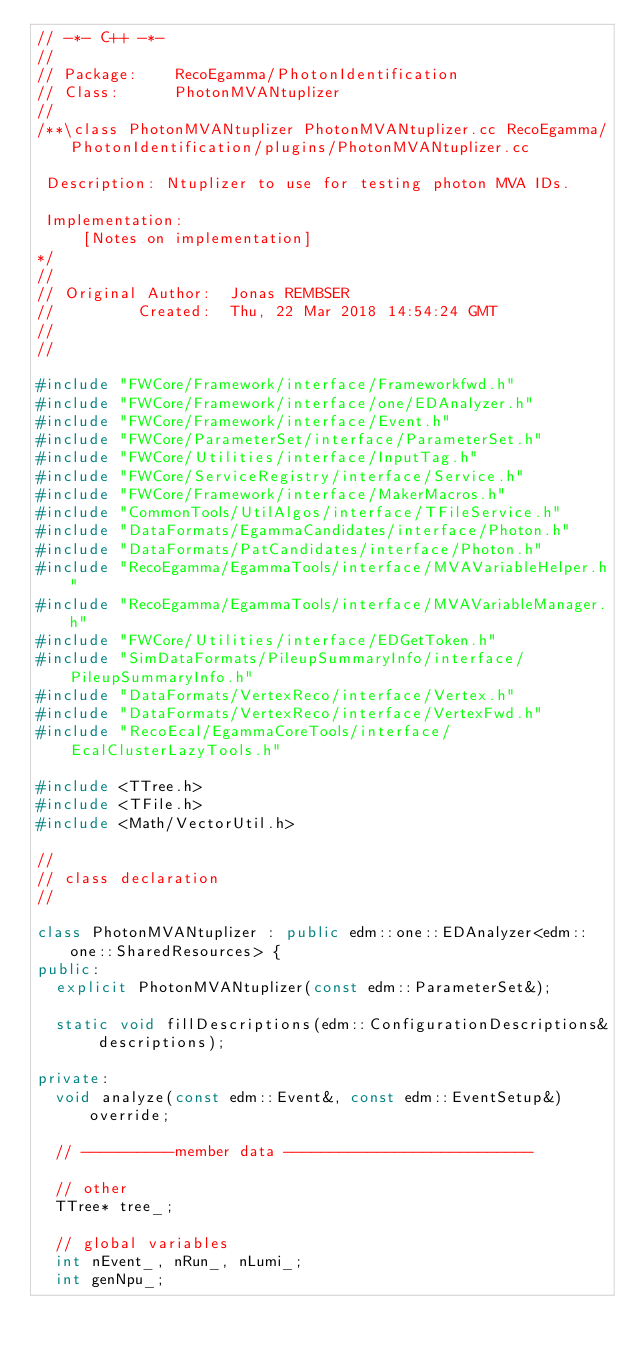Convert code to text. <code><loc_0><loc_0><loc_500><loc_500><_C++_>// -*- C++ -*-
//
// Package:    RecoEgamma/PhotonIdentification
// Class:      PhotonMVANtuplizer
//
/**\class PhotonMVANtuplizer PhotonMVANtuplizer.cc RecoEgamma/PhotonIdentification/plugins/PhotonMVANtuplizer.cc

 Description: Ntuplizer to use for testing photon MVA IDs.

 Implementation:
     [Notes on implementation]
*/
//
// Original Author:  Jonas REMBSER
//         Created:  Thu, 22 Mar 2018 14:54:24 GMT
//
//

#include "FWCore/Framework/interface/Frameworkfwd.h"
#include "FWCore/Framework/interface/one/EDAnalyzer.h"
#include "FWCore/Framework/interface/Event.h"
#include "FWCore/ParameterSet/interface/ParameterSet.h"
#include "FWCore/Utilities/interface/InputTag.h"
#include "FWCore/ServiceRegistry/interface/Service.h"
#include "FWCore/Framework/interface/MakerMacros.h"
#include "CommonTools/UtilAlgos/interface/TFileService.h"
#include "DataFormats/EgammaCandidates/interface/Photon.h"
#include "DataFormats/PatCandidates/interface/Photon.h"
#include "RecoEgamma/EgammaTools/interface/MVAVariableHelper.h"
#include "RecoEgamma/EgammaTools/interface/MVAVariableManager.h"
#include "FWCore/Utilities/interface/EDGetToken.h"
#include "SimDataFormats/PileupSummaryInfo/interface/PileupSummaryInfo.h"
#include "DataFormats/VertexReco/interface/Vertex.h"
#include "DataFormats/VertexReco/interface/VertexFwd.h"
#include "RecoEcal/EgammaCoreTools/interface/EcalClusterLazyTools.h"

#include <TTree.h>
#include <TFile.h>
#include <Math/VectorUtil.h>

//
// class declaration
//

class PhotonMVANtuplizer : public edm::one::EDAnalyzer<edm::one::SharedResources> {
public:
  explicit PhotonMVANtuplizer(const edm::ParameterSet&);

  static void fillDescriptions(edm::ConfigurationDescriptions& descriptions);

private:
  void analyze(const edm::Event&, const edm::EventSetup&) override;

  // ----------member data ---------------------------

  // other
  TTree* tree_;

  // global variables
  int nEvent_, nRun_, nLumi_;
  int genNpu_;</code> 